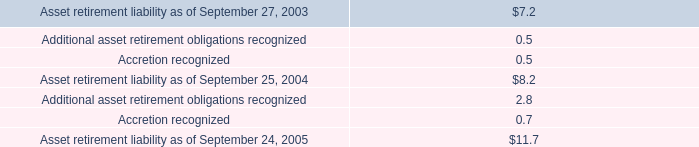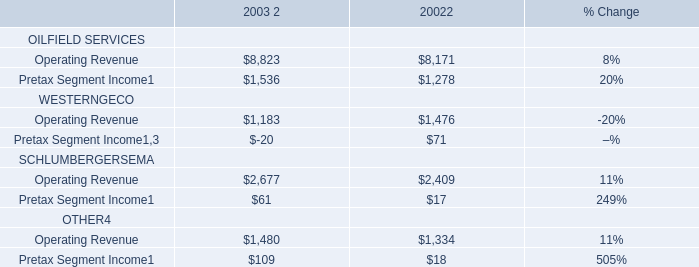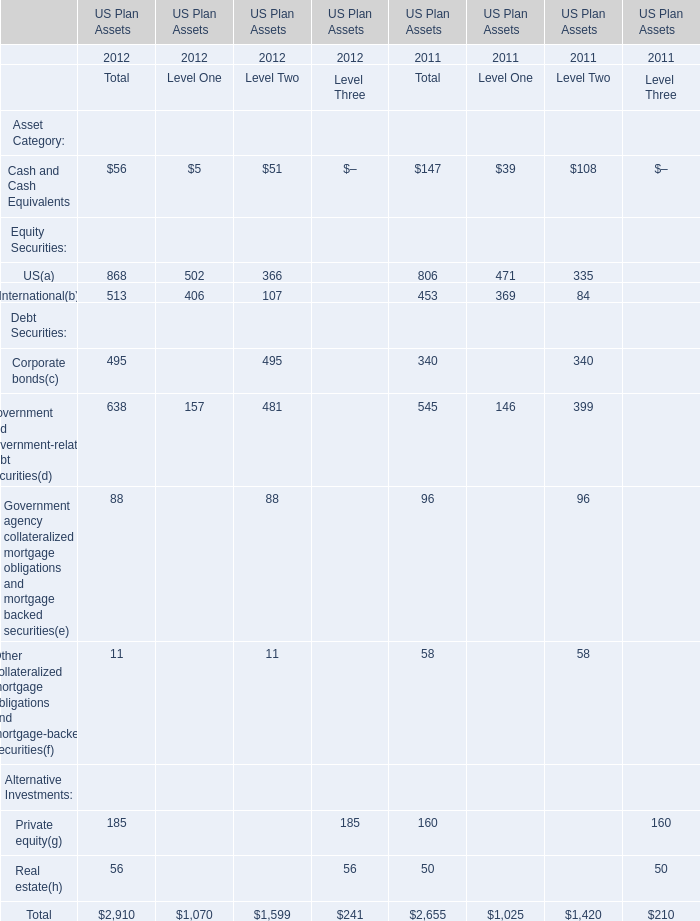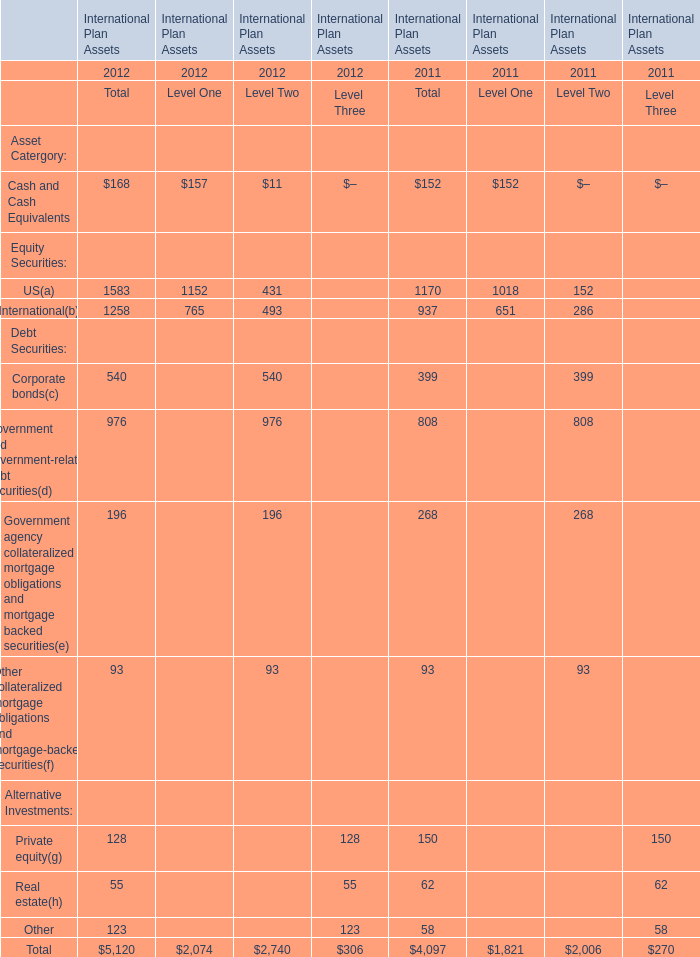What is the growing rate of Corporate bonds for total in the years with the least International? 
Computations: ((495 - 340) / 340)
Answer: 0.45588. 